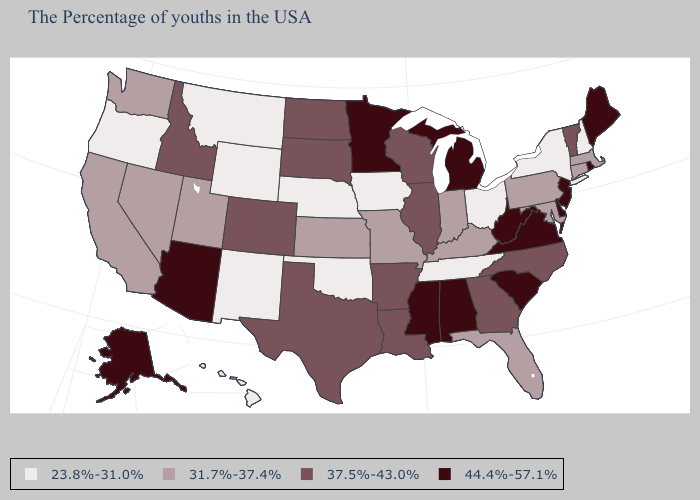Which states have the lowest value in the West?
Concise answer only. Wyoming, New Mexico, Montana, Oregon, Hawaii. Name the states that have a value in the range 31.7%-37.4%?
Give a very brief answer. Massachusetts, Connecticut, Maryland, Pennsylvania, Florida, Kentucky, Indiana, Missouri, Kansas, Utah, Nevada, California, Washington. Is the legend a continuous bar?
Write a very short answer. No. Name the states that have a value in the range 37.5%-43.0%?
Answer briefly. Vermont, North Carolina, Georgia, Wisconsin, Illinois, Louisiana, Arkansas, Texas, South Dakota, North Dakota, Colorado, Idaho. What is the value of Hawaii?
Be succinct. 23.8%-31.0%. Does Minnesota have the highest value in the USA?
Concise answer only. Yes. What is the lowest value in the USA?
Concise answer only. 23.8%-31.0%. Name the states that have a value in the range 37.5%-43.0%?
Keep it brief. Vermont, North Carolina, Georgia, Wisconsin, Illinois, Louisiana, Arkansas, Texas, South Dakota, North Dakota, Colorado, Idaho. Does New York have the lowest value in the Northeast?
Keep it brief. Yes. What is the value of Utah?
Quick response, please. 31.7%-37.4%. What is the value of Hawaii?
Answer briefly. 23.8%-31.0%. What is the lowest value in states that border Arkansas?
Give a very brief answer. 23.8%-31.0%. How many symbols are there in the legend?
Give a very brief answer. 4. Among the states that border Texas , does Louisiana have the highest value?
Give a very brief answer. Yes. 